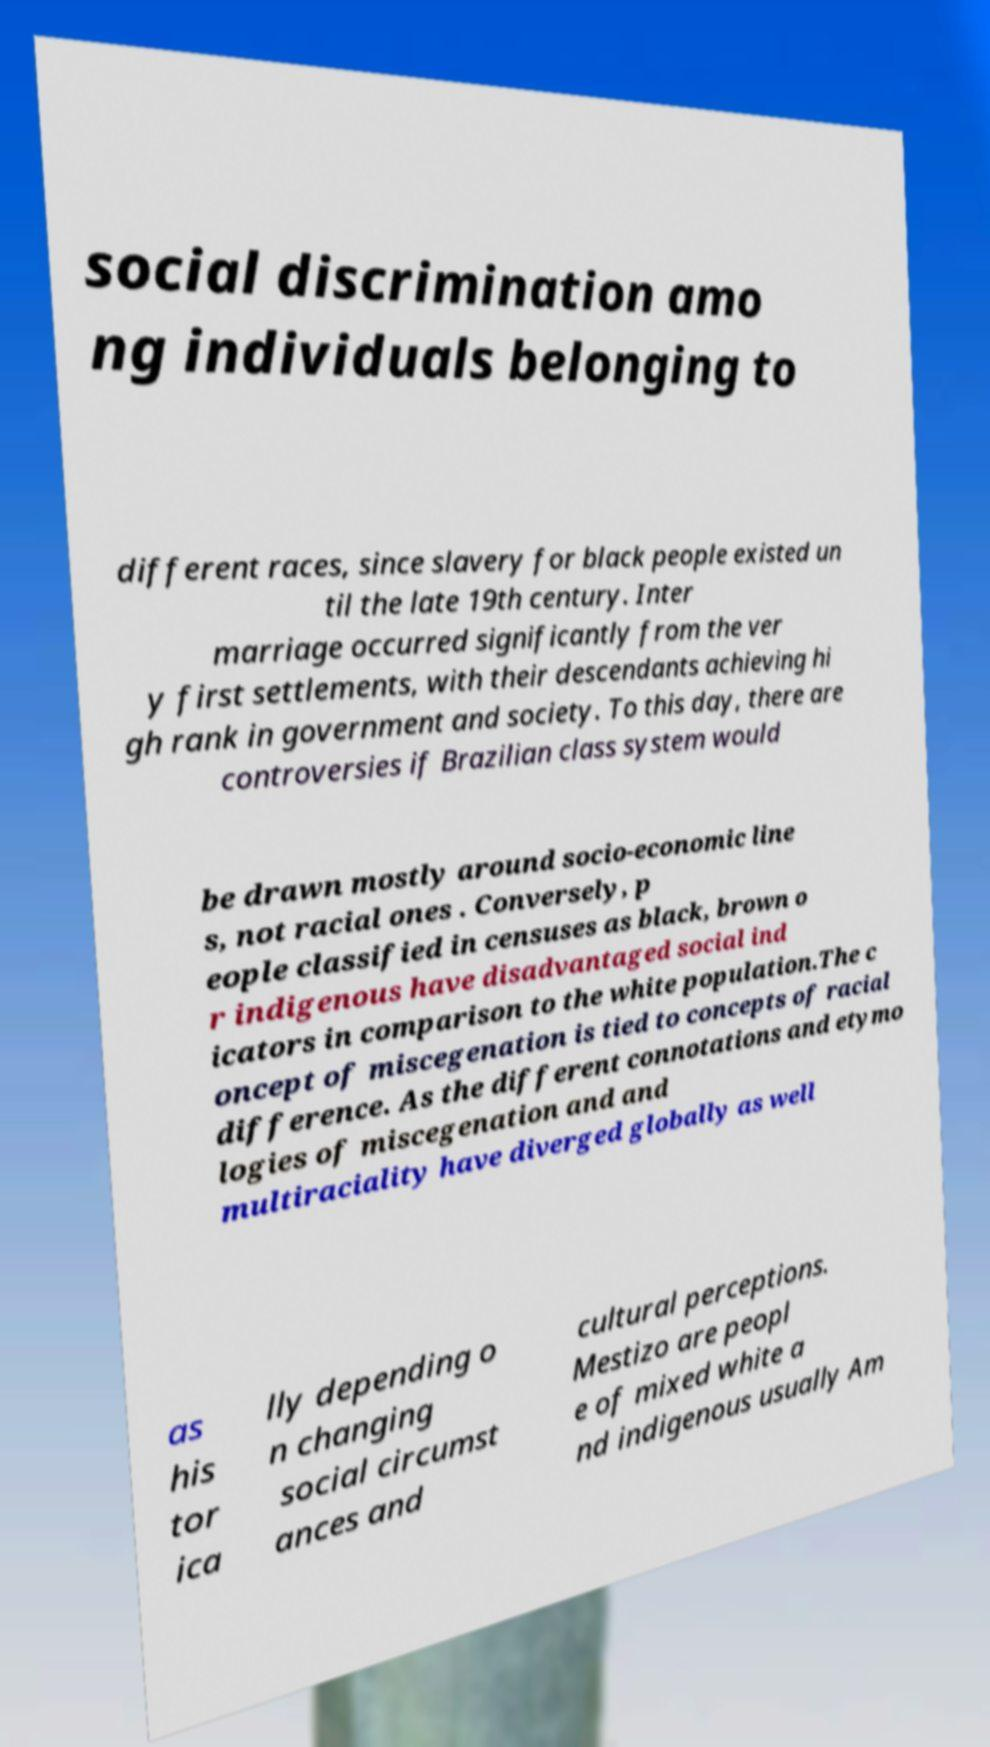Could you extract and type out the text from this image? social discrimination amo ng individuals belonging to different races, since slavery for black people existed un til the late 19th century. Inter marriage occurred significantly from the ver y first settlements, with their descendants achieving hi gh rank in government and society. To this day, there are controversies if Brazilian class system would be drawn mostly around socio-economic line s, not racial ones . Conversely, p eople classified in censuses as black, brown o r indigenous have disadvantaged social ind icators in comparison to the white population.The c oncept of miscegenation is tied to concepts of racial difference. As the different connotations and etymo logies of miscegenation and and multiraciality have diverged globally as well as his tor ica lly depending o n changing social circumst ances and cultural perceptions. Mestizo are peopl e of mixed white a nd indigenous usually Am 